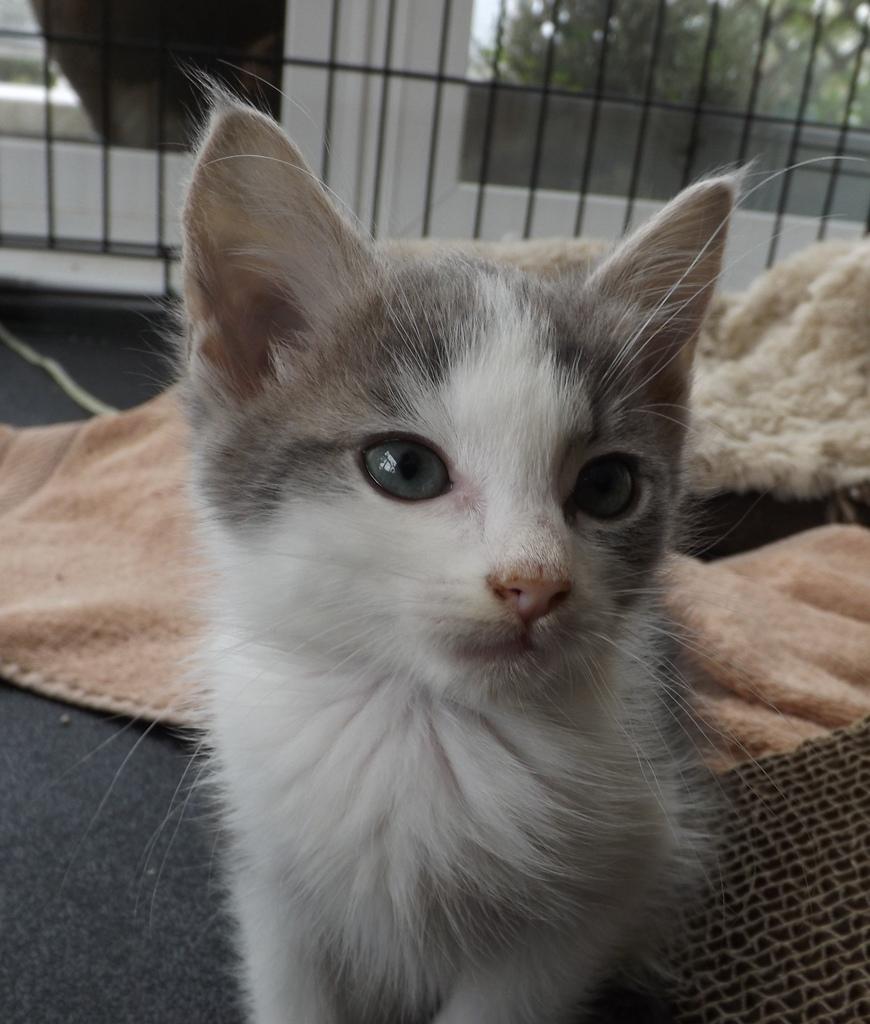Describe this image in one or two sentences. In this image at front there is a cat. Behind her there are mats. At the back side there is a window. In front of the window metal fencing was done. At the background there are trees. 